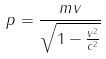<formula> <loc_0><loc_0><loc_500><loc_500>p = \frac { m v } { \sqrt { 1 - \frac { v ^ { 2 } } { c ^ { 2 } } } }</formula> 